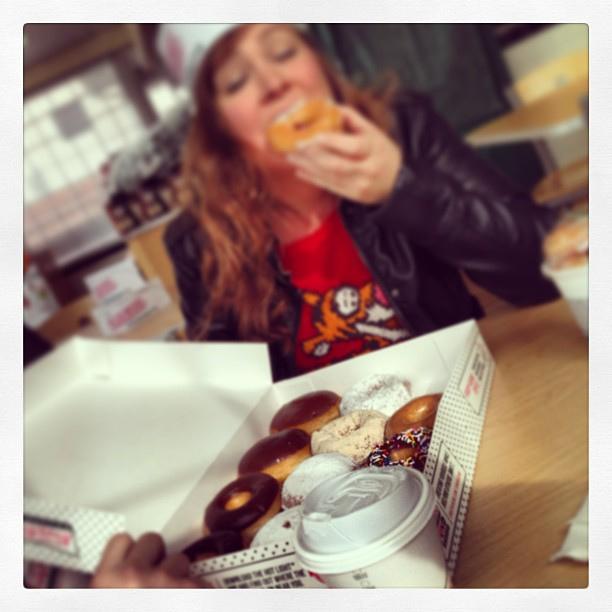How many donuts has the lady eaten?
Concise answer only. 1. Where is the cup of coffee?
Quick response, please. Foreground. Does the girl have long hair?
Keep it brief. Yes. 